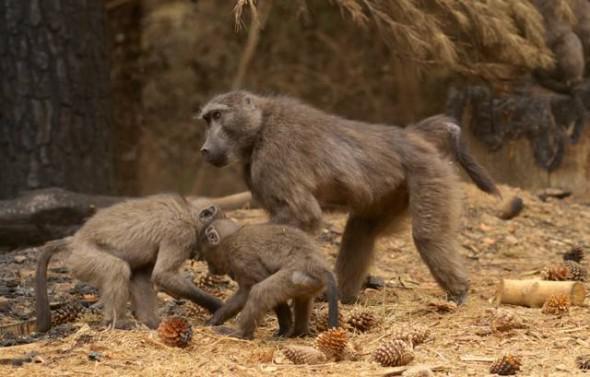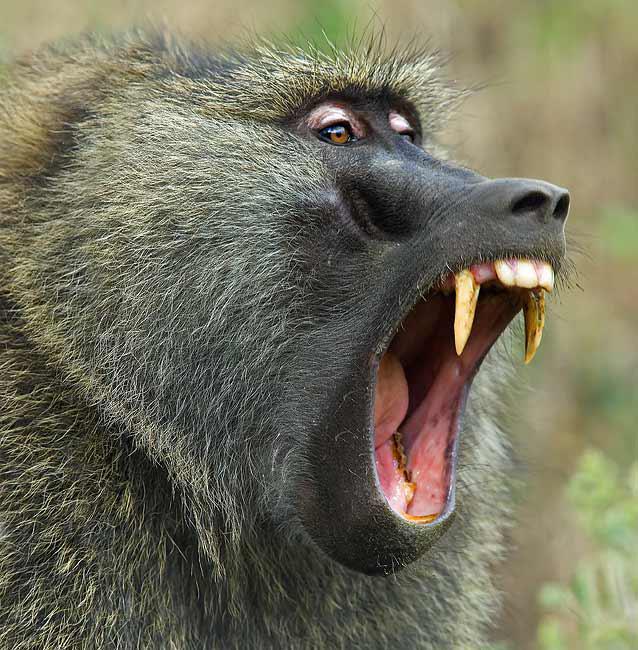The first image is the image on the left, the second image is the image on the right. Given the left and right images, does the statement "Each image contains multiple baboons but less than five baboons, and one image includes a baby baboon clinging to the chest of an adult baboon." hold true? Answer yes or no. No. The first image is the image on the left, the second image is the image on the right. Analyze the images presented: Is the assertion "One ape's teeth are visible." valid? Answer yes or no. Yes. 